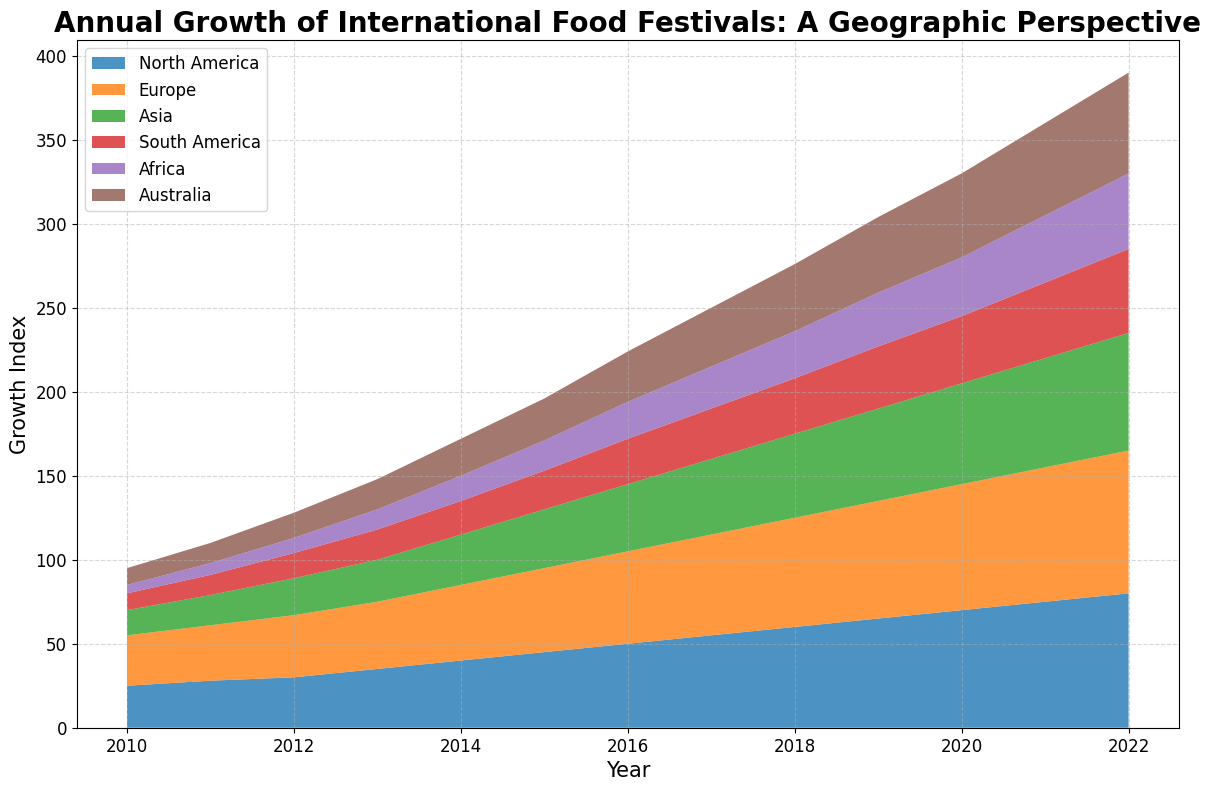What region showed the highest growth in 2022? Look at the area chart for the year 2022 and identify which region's colored area is the largest. The region with the largest area will have the highest growth.
Answer: Europe Which two regions had the smallest growth in 2010 and 2011, respectively? Locate the areas for the years 2010 and 2011. Compare the height of the colored areas for all regions, and identify the two with the smallest heights.
Answer: Africa and South America How much did the growth index in North America increase between 2010 and 2022? Find the difference in height of the North America area from 2010 to 2022. The growth for North America in 2010 is 25, and in 2022 it is 80. Calculate 80 - 25.
Answer: 55 Which region had a greater increase in growth index between 2010 and 2022, Asia or South America, and by how much? Subtract the growth index value of 2010 from that of 2022 for both Asia and South America. For Asia: 70 - 15 = 55. For South America: 50 - 10 = 40. Then compare the results, 55 for Asia and 40 for South America, to find the difference.
Answer: Asia by 15 By how much did the growth index for Europe surpass that of North America in 2018? Identify the growth index values for Europe and North America in 2018. Europe is 65 and North America is 60. Subtract the value of North America from Europe, which is 65 - 60.
Answer: 5 In which year did Australia see its growth index double compared to its 2011 value, and what was that value? Australia’s growth index in 2011 is 12. Determine when the value reached double, which is 24. Look at the plotted values: in 2013, it surpasses 24, precisely at 25.
Answer: 2013, 25 What is the average growth index for Africa over the period 2015 to 2020? Sum up Africa's growth index values from 2015 to 2020 (18, 22, 25, 28, 32, and 35) and divide by the number of years (6). The sum is 160, and the average is 160 / 6.
Answer: 26.67 Which year did North America achieve a growth index value of 50, and how many other regions had a higher value that year? Find the year in the chart when North America's growth index first hits 50, which is 2016. Then, count how many regions have higher values in that same year (Europe, and Australia).
Answer: 2016, 2 What is the total increase in the growth index for South America from 2010 to 2021? Subtract the 2010 value from the 2021 value for South America. The 2010 value is 10, and the 2021 value is 45. Calculate 45 - 10.
Answer: 35 Which region experienced the greatest increase in growth index from 2013 to 2016? Calculate the growth difference for each region between 2013 and 2016. For North America: 50 - 35 = 15. For Europe: 55 - 40 = 15. For Asia: 40 - 25 = 15. For South America: 27 - 18 = 9. For Africa: 22 - 12 = 10. For Australia: 30 - 18 = 12. North America, Europe, and Asia all had the highest increase.
Answer: North America, Europe, and Asia 